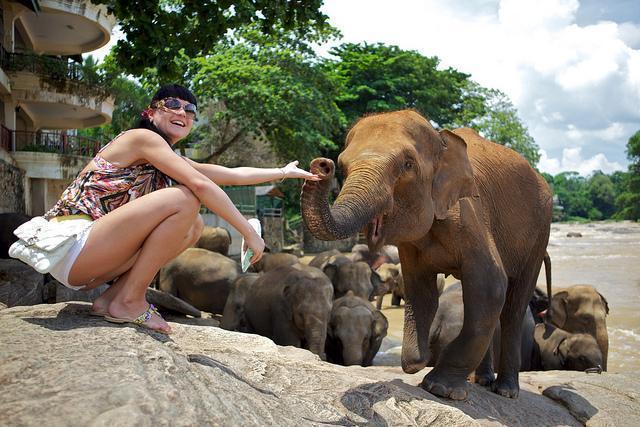What is the woman wearing?
Make your selection from the four choices given to correctly answer the question.
Options: Bandana, hat, jeans, sandals. Sandals. What is climbing up the rocks to talk to the woman who is on the top?
Choose the right answer and clarify with the format: 'Answer: answer
Rationale: rationale.'
Options: Wolf, seal, elephant, penguin. Answer: elephant.
Rationale: A large animal with a trunk approaches a girl. 